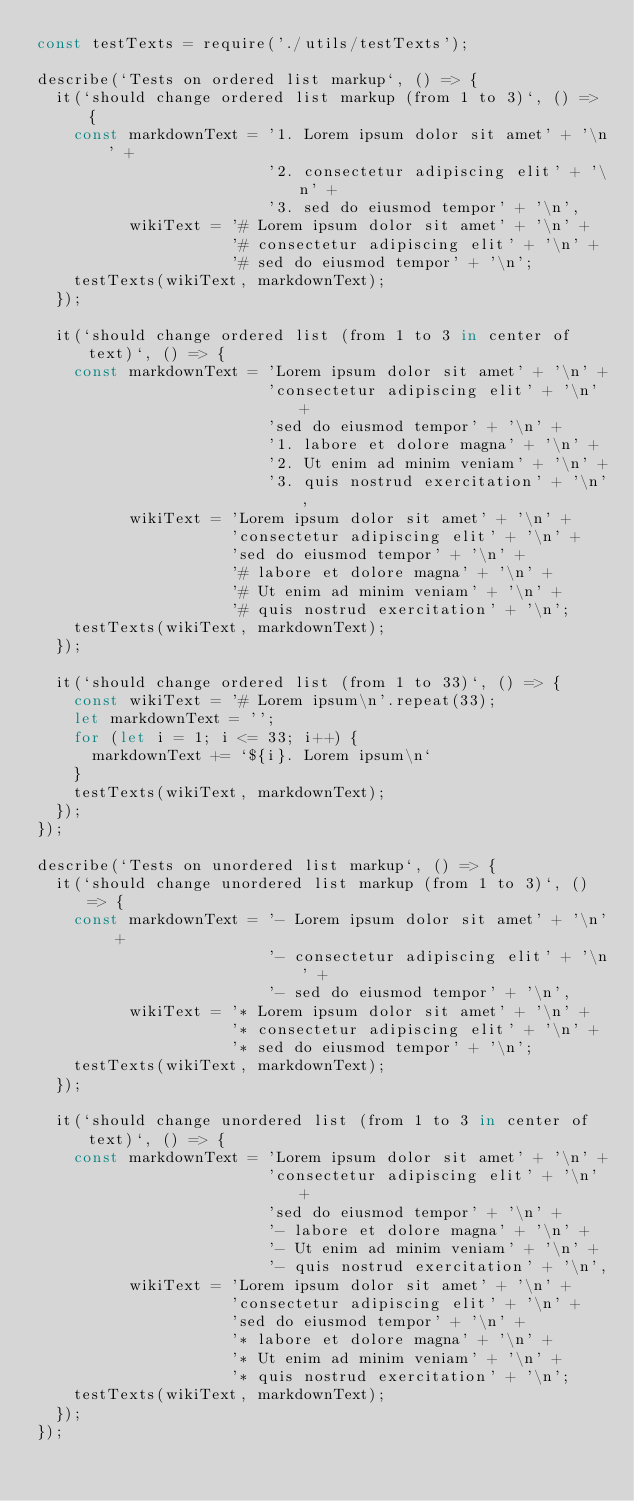<code> <loc_0><loc_0><loc_500><loc_500><_JavaScript_>const testTexts = require('./utils/testTexts');

describe(`Tests on ordered list markup`, () => {
  it(`should change ordered list markup (from 1 to 3)`, () => {
    const markdownText = '1. Lorem ipsum dolor sit amet' + '\n' +
                         '2. consectetur adipiscing elit' + '\n' +
                         '3. sed do eiusmod tempor' + '\n',
          wikiText = '# Lorem ipsum dolor sit amet' + '\n' +
                     '# consectetur adipiscing elit' + '\n' +
                     '# sed do eiusmod tempor' + '\n';
    testTexts(wikiText, markdownText);
  });

  it(`should change ordered list (from 1 to 3 in center of text)`, () => {
    const markdownText = 'Lorem ipsum dolor sit amet' + '\n' +
                         'consectetur adipiscing elit' + '\n' +
                         'sed do eiusmod tempor' + '\n' +
                         '1. labore et dolore magna' + '\n' +
                         '2. Ut enim ad minim veniam' + '\n' +
                         '3. quis nostrud exercitation' + '\n',
          wikiText = 'Lorem ipsum dolor sit amet' + '\n' +
                     'consectetur adipiscing elit' + '\n' +
                     'sed do eiusmod tempor' + '\n' +
                     '# labore et dolore magna' + '\n' +
                     '# Ut enim ad minim veniam' + '\n' +
                     '# quis nostrud exercitation' + '\n';
    testTexts(wikiText, markdownText);
  });

  it(`should change ordered list (from 1 to 33)`, () => {
    const wikiText = '# Lorem ipsum\n'.repeat(33);
    let markdownText = '';
    for (let i = 1; i <= 33; i++) {
      markdownText += `${i}. Lorem ipsum\n`
    }
    testTexts(wikiText, markdownText);
  });
});

describe(`Tests on unordered list markup`, () => {
  it(`should change unordered list markup (from 1 to 3)`, () => {
    const markdownText = '- Lorem ipsum dolor sit amet' + '\n' +
                         '- consectetur adipiscing elit' + '\n' +
                         '- sed do eiusmod tempor' + '\n',
          wikiText = '* Lorem ipsum dolor sit amet' + '\n' +
                     '* consectetur adipiscing elit' + '\n' +
                     '* sed do eiusmod tempor' + '\n';
    testTexts(wikiText, markdownText);
  });

  it(`should change unordered list (from 1 to 3 in center of text)`, () => {
    const markdownText = 'Lorem ipsum dolor sit amet' + '\n' +
                         'consectetur adipiscing elit' + '\n' +
                         'sed do eiusmod tempor' + '\n' +
                         '- labore et dolore magna' + '\n' +
                         '- Ut enim ad minim veniam' + '\n' +
                         '- quis nostrud exercitation' + '\n',
          wikiText = 'Lorem ipsum dolor sit amet' + '\n' +
                     'consectetur adipiscing elit' + '\n' +
                     'sed do eiusmod tempor' + '\n' +
                     '* labore et dolore magna' + '\n' +
                     '* Ut enim ad minim veniam' + '\n' +
                     '* quis nostrud exercitation' + '\n';
    testTexts(wikiText, markdownText);
  });
});
</code> 